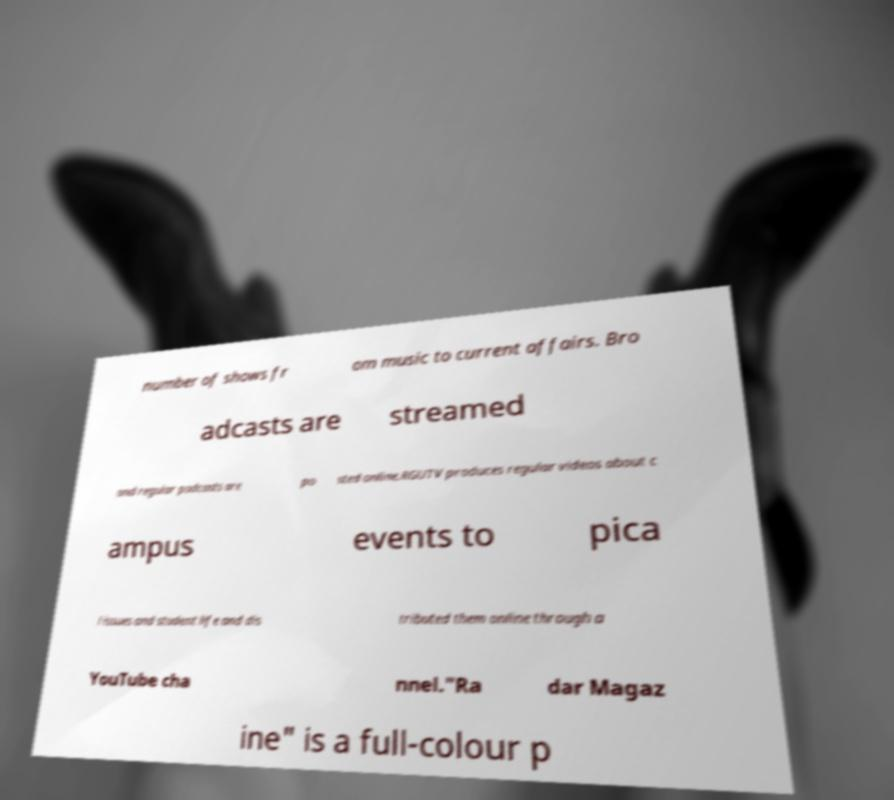Please identify and transcribe the text found in this image. number of shows fr om music to current affairs. Bro adcasts are streamed and regular podcasts are po sted online.RGUTV produces regular videos about c ampus events to pica l issues and student life and dis tributed them online through a YouTube cha nnel."Ra dar Magaz ine" is a full-colour p 